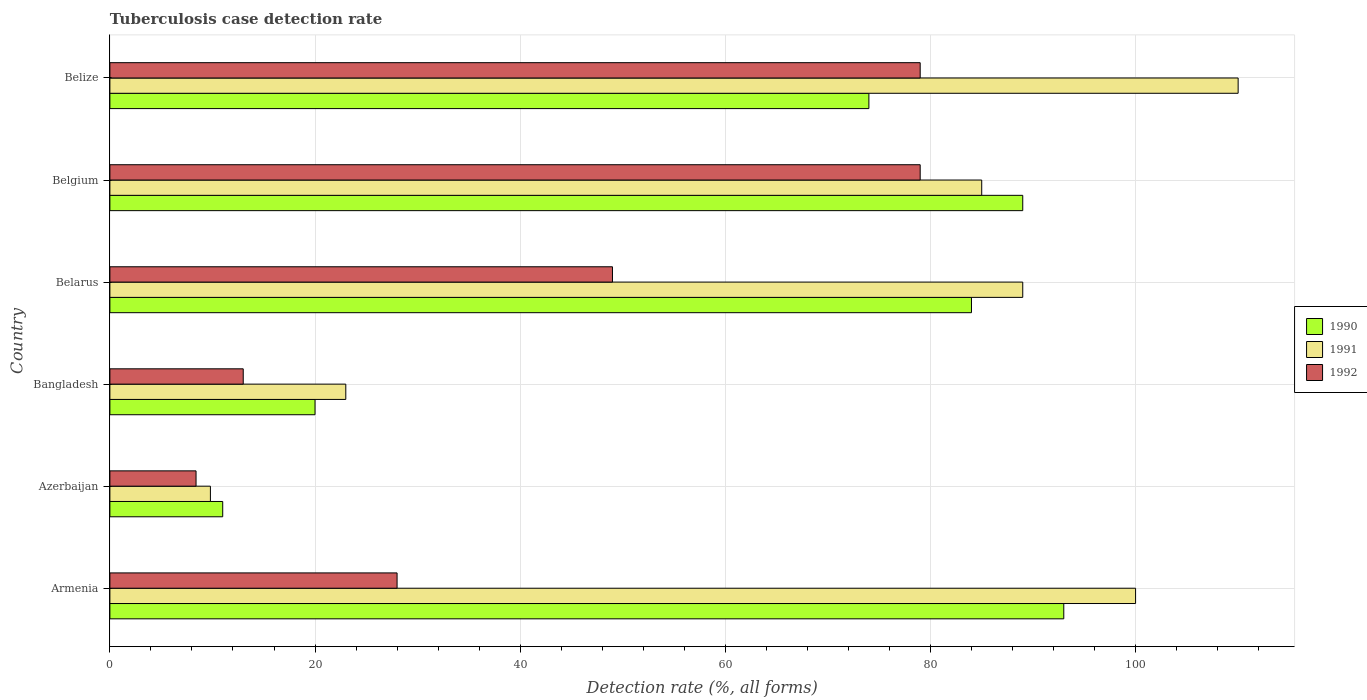How many groups of bars are there?
Offer a very short reply. 6. How many bars are there on the 5th tick from the bottom?
Offer a terse response. 3. What is the label of the 2nd group of bars from the top?
Provide a succinct answer. Belgium. What is the tuberculosis case detection rate in in 1992 in Belgium?
Your answer should be compact. 79. Across all countries, what is the maximum tuberculosis case detection rate in in 1992?
Give a very brief answer. 79. Across all countries, what is the minimum tuberculosis case detection rate in in 1991?
Give a very brief answer. 9.8. In which country was the tuberculosis case detection rate in in 1990 maximum?
Provide a short and direct response. Armenia. In which country was the tuberculosis case detection rate in in 1992 minimum?
Give a very brief answer. Azerbaijan. What is the total tuberculosis case detection rate in in 1992 in the graph?
Offer a very short reply. 256.4. What is the difference between the tuberculosis case detection rate in in 1992 in Belgium and that in Belize?
Offer a terse response. 0. What is the difference between the tuberculosis case detection rate in in 1992 in Belize and the tuberculosis case detection rate in in 1991 in Belarus?
Make the answer very short. -10. What is the average tuberculosis case detection rate in in 1990 per country?
Your answer should be very brief. 61.83. What is the difference between the tuberculosis case detection rate in in 1992 and tuberculosis case detection rate in in 1990 in Belarus?
Make the answer very short. -35. In how many countries, is the tuberculosis case detection rate in in 1990 greater than 28 %?
Your answer should be compact. 4. What is the ratio of the tuberculosis case detection rate in in 1992 in Bangladesh to that in Belgium?
Ensure brevity in your answer.  0.16. Is the tuberculosis case detection rate in in 1992 in Azerbaijan less than that in Belarus?
Keep it short and to the point. Yes. What is the difference between the highest and the second highest tuberculosis case detection rate in in 1992?
Your answer should be very brief. 0. What is the difference between the highest and the lowest tuberculosis case detection rate in in 1991?
Your answer should be compact. 100.2. In how many countries, is the tuberculosis case detection rate in in 1990 greater than the average tuberculosis case detection rate in in 1990 taken over all countries?
Provide a short and direct response. 4. Is the sum of the tuberculosis case detection rate in in 1990 in Armenia and Bangladesh greater than the maximum tuberculosis case detection rate in in 1992 across all countries?
Your answer should be very brief. Yes. What does the 3rd bar from the top in Bangladesh represents?
Ensure brevity in your answer.  1990. Is it the case that in every country, the sum of the tuberculosis case detection rate in in 1991 and tuberculosis case detection rate in in 1992 is greater than the tuberculosis case detection rate in in 1990?
Your answer should be compact. Yes. How many countries are there in the graph?
Offer a terse response. 6. Does the graph contain any zero values?
Offer a terse response. No. Where does the legend appear in the graph?
Provide a short and direct response. Center right. How many legend labels are there?
Your answer should be very brief. 3. How are the legend labels stacked?
Make the answer very short. Vertical. What is the title of the graph?
Make the answer very short. Tuberculosis case detection rate. What is the label or title of the X-axis?
Offer a terse response. Detection rate (%, all forms). What is the label or title of the Y-axis?
Ensure brevity in your answer.  Country. What is the Detection rate (%, all forms) in 1990 in Armenia?
Ensure brevity in your answer.  93. What is the Detection rate (%, all forms) in 1991 in Azerbaijan?
Make the answer very short. 9.8. What is the Detection rate (%, all forms) of 1992 in Azerbaijan?
Offer a terse response. 8.4. What is the Detection rate (%, all forms) of 1992 in Bangladesh?
Keep it short and to the point. 13. What is the Detection rate (%, all forms) of 1990 in Belarus?
Make the answer very short. 84. What is the Detection rate (%, all forms) in 1991 in Belarus?
Your answer should be very brief. 89. What is the Detection rate (%, all forms) of 1992 in Belarus?
Make the answer very short. 49. What is the Detection rate (%, all forms) of 1990 in Belgium?
Your answer should be compact. 89. What is the Detection rate (%, all forms) in 1992 in Belgium?
Make the answer very short. 79. What is the Detection rate (%, all forms) of 1990 in Belize?
Your answer should be very brief. 74. What is the Detection rate (%, all forms) of 1991 in Belize?
Ensure brevity in your answer.  110. What is the Detection rate (%, all forms) in 1992 in Belize?
Provide a short and direct response. 79. Across all countries, what is the maximum Detection rate (%, all forms) in 1990?
Make the answer very short. 93. Across all countries, what is the maximum Detection rate (%, all forms) in 1991?
Make the answer very short. 110. Across all countries, what is the maximum Detection rate (%, all forms) of 1992?
Give a very brief answer. 79. Across all countries, what is the minimum Detection rate (%, all forms) of 1990?
Your answer should be very brief. 11. Across all countries, what is the minimum Detection rate (%, all forms) of 1991?
Keep it short and to the point. 9.8. What is the total Detection rate (%, all forms) in 1990 in the graph?
Provide a succinct answer. 371. What is the total Detection rate (%, all forms) in 1991 in the graph?
Ensure brevity in your answer.  416.8. What is the total Detection rate (%, all forms) of 1992 in the graph?
Give a very brief answer. 256.4. What is the difference between the Detection rate (%, all forms) in 1990 in Armenia and that in Azerbaijan?
Make the answer very short. 82. What is the difference between the Detection rate (%, all forms) in 1991 in Armenia and that in Azerbaijan?
Offer a terse response. 90.2. What is the difference between the Detection rate (%, all forms) in 1992 in Armenia and that in Azerbaijan?
Keep it short and to the point. 19.6. What is the difference between the Detection rate (%, all forms) of 1991 in Armenia and that in Bangladesh?
Your response must be concise. 77. What is the difference between the Detection rate (%, all forms) in 1992 in Armenia and that in Bangladesh?
Offer a very short reply. 15. What is the difference between the Detection rate (%, all forms) in 1990 in Armenia and that in Belarus?
Provide a short and direct response. 9. What is the difference between the Detection rate (%, all forms) of 1991 in Armenia and that in Belarus?
Give a very brief answer. 11. What is the difference between the Detection rate (%, all forms) of 1992 in Armenia and that in Belarus?
Give a very brief answer. -21. What is the difference between the Detection rate (%, all forms) in 1991 in Armenia and that in Belgium?
Make the answer very short. 15. What is the difference between the Detection rate (%, all forms) of 1992 in Armenia and that in Belgium?
Give a very brief answer. -51. What is the difference between the Detection rate (%, all forms) of 1990 in Armenia and that in Belize?
Make the answer very short. 19. What is the difference between the Detection rate (%, all forms) of 1991 in Armenia and that in Belize?
Your answer should be very brief. -10. What is the difference between the Detection rate (%, all forms) in 1992 in Armenia and that in Belize?
Offer a very short reply. -51. What is the difference between the Detection rate (%, all forms) of 1990 in Azerbaijan and that in Bangladesh?
Provide a short and direct response. -9. What is the difference between the Detection rate (%, all forms) in 1991 in Azerbaijan and that in Bangladesh?
Your answer should be compact. -13.2. What is the difference between the Detection rate (%, all forms) in 1992 in Azerbaijan and that in Bangladesh?
Offer a very short reply. -4.6. What is the difference between the Detection rate (%, all forms) of 1990 in Azerbaijan and that in Belarus?
Offer a terse response. -73. What is the difference between the Detection rate (%, all forms) in 1991 in Azerbaijan and that in Belarus?
Your response must be concise. -79.2. What is the difference between the Detection rate (%, all forms) of 1992 in Azerbaijan and that in Belarus?
Provide a succinct answer. -40.6. What is the difference between the Detection rate (%, all forms) of 1990 in Azerbaijan and that in Belgium?
Ensure brevity in your answer.  -78. What is the difference between the Detection rate (%, all forms) of 1991 in Azerbaijan and that in Belgium?
Keep it short and to the point. -75.2. What is the difference between the Detection rate (%, all forms) in 1992 in Azerbaijan and that in Belgium?
Your answer should be compact. -70.6. What is the difference between the Detection rate (%, all forms) of 1990 in Azerbaijan and that in Belize?
Ensure brevity in your answer.  -63. What is the difference between the Detection rate (%, all forms) in 1991 in Azerbaijan and that in Belize?
Give a very brief answer. -100.2. What is the difference between the Detection rate (%, all forms) of 1992 in Azerbaijan and that in Belize?
Provide a short and direct response. -70.6. What is the difference between the Detection rate (%, all forms) in 1990 in Bangladesh and that in Belarus?
Your answer should be very brief. -64. What is the difference between the Detection rate (%, all forms) in 1991 in Bangladesh and that in Belarus?
Offer a very short reply. -66. What is the difference between the Detection rate (%, all forms) in 1992 in Bangladesh and that in Belarus?
Provide a succinct answer. -36. What is the difference between the Detection rate (%, all forms) of 1990 in Bangladesh and that in Belgium?
Keep it short and to the point. -69. What is the difference between the Detection rate (%, all forms) in 1991 in Bangladesh and that in Belgium?
Offer a terse response. -62. What is the difference between the Detection rate (%, all forms) of 1992 in Bangladesh and that in Belgium?
Ensure brevity in your answer.  -66. What is the difference between the Detection rate (%, all forms) in 1990 in Bangladesh and that in Belize?
Your answer should be very brief. -54. What is the difference between the Detection rate (%, all forms) in 1991 in Bangladesh and that in Belize?
Provide a succinct answer. -87. What is the difference between the Detection rate (%, all forms) in 1992 in Bangladesh and that in Belize?
Offer a terse response. -66. What is the difference between the Detection rate (%, all forms) of 1990 in Belarus and that in Belgium?
Provide a short and direct response. -5. What is the difference between the Detection rate (%, all forms) of 1991 in Belarus and that in Belgium?
Keep it short and to the point. 4. What is the difference between the Detection rate (%, all forms) of 1990 in Belarus and that in Belize?
Give a very brief answer. 10. What is the difference between the Detection rate (%, all forms) in 1990 in Belgium and that in Belize?
Your answer should be compact. 15. What is the difference between the Detection rate (%, all forms) in 1992 in Belgium and that in Belize?
Your response must be concise. 0. What is the difference between the Detection rate (%, all forms) of 1990 in Armenia and the Detection rate (%, all forms) of 1991 in Azerbaijan?
Give a very brief answer. 83.2. What is the difference between the Detection rate (%, all forms) in 1990 in Armenia and the Detection rate (%, all forms) in 1992 in Azerbaijan?
Offer a terse response. 84.6. What is the difference between the Detection rate (%, all forms) in 1991 in Armenia and the Detection rate (%, all forms) in 1992 in Azerbaijan?
Provide a short and direct response. 91.6. What is the difference between the Detection rate (%, all forms) in 1990 in Armenia and the Detection rate (%, all forms) in 1991 in Bangladesh?
Provide a short and direct response. 70. What is the difference between the Detection rate (%, all forms) in 1990 in Armenia and the Detection rate (%, all forms) in 1992 in Bangladesh?
Offer a terse response. 80. What is the difference between the Detection rate (%, all forms) of 1990 in Armenia and the Detection rate (%, all forms) of 1992 in Belize?
Your response must be concise. 14. What is the difference between the Detection rate (%, all forms) in 1991 in Armenia and the Detection rate (%, all forms) in 1992 in Belize?
Provide a succinct answer. 21. What is the difference between the Detection rate (%, all forms) in 1990 in Azerbaijan and the Detection rate (%, all forms) in 1991 in Bangladesh?
Offer a terse response. -12. What is the difference between the Detection rate (%, all forms) of 1991 in Azerbaijan and the Detection rate (%, all forms) of 1992 in Bangladesh?
Your answer should be very brief. -3.2. What is the difference between the Detection rate (%, all forms) in 1990 in Azerbaijan and the Detection rate (%, all forms) in 1991 in Belarus?
Provide a succinct answer. -78. What is the difference between the Detection rate (%, all forms) in 1990 in Azerbaijan and the Detection rate (%, all forms) in 1992 in Belarus?
Offer a very short reply. -38. What is the difference between the Detection rate (%, all forms) in 1991 in Azerbaijan and the Detection rate (%, all forms) in 1992 in Belarus?
Provide a short and direct response. -39.2. What is the difference between the Detection rate (%, all forms) in 1990 in Azerbaijan and the Detection rate (%, all forms) in 1991 in Belgium?
Offer a very short reply. -74. What is the difference between the Detection rate (%, all forms) of 1990 in Azerbaijan and the Detection rate (%, all forms) of 1992 in Belgium?
Provide a short and direct response. -68. What is the difference between the Detection rate (%, all forms) in 1991 in Azerbaijan and the Detection rate (%, all forms) in 1992 in Belgium?
Give a very brief answer. -69.2. What is the difference between the Detection rate (%, all forms) of 1990 in Azerbaijan and the Detection rate (%, all forms) of 1991 in Belize?
Your answer should be very brief. -99. What is the difference between the Detection rate (%, all forms) in 1990 in Azerbaijan and the Detection rate (%, all forms) in 1992 in Belize?
Give a very brief answer. -68. What is the difference between the Detection rate (%, all forms) in 1991 in Azerbaijan and the Detection rate (%, all forms) in 1992 in Belize?
Your answer should be compact. -69.2. What is the difference between the Detection rate (%, all forms) in 1990 in Bangladesh and the Detection rate (%, all forms) in 1991 in Belarus?
Your response must be concise. -69. What is the difference between the Detection rate (%, all forms) in 1990 in Bangladesh and the Detection rate (%, all forms) in 1991 in Belgium?
Offer a very short reply. -65. What is the difference between the Detection rate (%, all forms) of 1990 in Bangladesh and the Detection rate (%, all forms) of 1992 in Belgium?
Your answer should be very brief. -59. What is the difference between the Detection rate (%, all forms) of 1991 in Bangladesh and the Detection rate (%, all forms) of 1992 in Belgium?
Offer a terse response. -56. What is the difference between the Detection rate (%, all forms) of 1990 in Bangladesh and the Detection rate (%, all forms) of 1991 in Belize?
Offer a very short reply. -90. What is the difference between the Detection rate (%, all forms) of 1990 in Bangladesh and the Detection rate (%, all forms) of 1992 in Belize?
Your answer should be very brief. -59. What is the difference between the Detection rate (%, all forms) of 1991 in Bangladesh and the Detection rate (%, all forms) of 1992 in Belize?
Offer a terse response. -56. What is the difference between the Detection rate (%, all forms) in 1990 in Belarus and the Detection rate (%, all forms) in 1991 in Belgium?
Give a very brief answer. -1. What is the difference between the Detection rate (%, all forms) of 1991 in Belarus and the Detection rate (%, all forms) of 1992 in Belgium?
Keep it short and to the point. 10. What is the difference between the Detection rate (%, all forms) of 1990 in Belarus and the Detection rate (%, all forms) of 1992 in Belize?
Provide a short and direct response. 5. What is the difference between the Detection rate (%, all forms) of 1990 in Belgium and the Detection rate (%, all forms) of 1992 in Belize?
Ensure brevity in your answer.  10. What is the difference between the Detection rate (%, all forms) of 1991 in Belgium and the Detection rate (%, all forms) of 1992 in Belize?
Provide a succinct answer. 6. What is the average Detection rate (%, all forms) of 1990 per country?
Make the answer very short. 61.83. What is the average Detection rate (%, all forms) in 1991 per country?
Your response must be concise. 69.47. What is the average Detection rate (%, all forms) of 1992 per country?
Offer a very short reply. 42.73. What is the difference between the Detection rate (%, all forms) of 1990 and Detection rate (%, all forms) of 1991 in Armenia?
Make the answer very short. -7. What is the difference between the Detection rate (%, all forms) of 1990 and Detection rate (%, all forms) of 1992 in Armenia?
Provide a short and direct response. 65. What is the difference between the Detection rate (%, all forms) of 1991 and Detection rate (%, all forms) of 1992 in Armenia?
Ensure brevity in your answer.  72. What is the difference between the Detection rate (%, all forms) of 1990 and Detection rate (%, all forms) of 1991 in Bangladesh?
Provide a short and direct response. -3. What is the difference between the Detection rate (%, all forms) of 1991 and Detection rate (%, all forms) of 1992 in Bangladesh?
Give a very brief answer. 10. What is the difference between the Detection rate (%, all forms) of 1990 and Detection rate (%, all forms) of 1991 in Belarus?
Offer a terse response. -5. What is the difference between the Detection rate (%, all forms) in 1991 and Detection rate (%, all forms) in 1992 in Belarus?
Provide a short and direct response. 40. What is the difference between the Detection rate (%, all forms) in 1990 and Detection rate (%, all forms) in 1991 in Belgium?
Your response must be concise. 4. What is the difference between the Detection rate (%, all forms) in 1990 and Detection rate (%, all forms) in 1991 in Belize?
Keep it short and to the point. -36. What is the difference between the Detection rate (%, all forms) in 1991 and Detection rate (%, all forms) in 1992 in Belize?
Provide a succinct answer. 31. What is the ratio of the Detection rate (%, all forms) of 1990 in Armenia to that in Azerbaijan?
Offer a terse response. 8.45. What is the ratio of the Detection rate (%, all forms) of 1991 in Armenia to that in Azerbaijan?
Keep it short and to the point. 10.2. What is the ratio of the Detection rate (%, all forms) in 1990 in Armenia to that in Bangladesh?
Give a very brief answer. 4.65. What is the ratio of the Detection rate (%, all forms) of 1991 in Armenia to that in Bangladesh?
Give a very brief answer. 4.35. What is the ratio of the Detection rate (%, all forms) of 1992 in Armenia to that in Bangladesh?
Ensure brevity in your answer.  2.15. What is the ratio of the Detection rate (%, all forms) in 1990 in Armenia to that in Belarus?
Your answer should be very brief. 1.11. What is the ratio of the Detection rate (%, all forms) of 1991 in Armenia to that in Belarus?
Give a very brief answer. 1.12. What is the ratio of the Detection rate (%, all forms) in 1992 in Armenia to that in Belarus?
Offer a terse response. 0.57. What is the ratio of the Detection rate (%, all forms) in 1990 in Armenia to that in Belgium?
Your response must be concise. 1.04. What is the ratio of the Detection rate (%, all forms) of 1991 in Armenia to that in Belgium?
Make the answer very short. 1.18. What is the ratio of the Detection rate (%, all forms) of 1992 in Armenia to that in Belgium?
Provide a succinct answer. 0.35. What is the ratio of the Detection rate (%, all forms) of 1990 in Armenia to that in Belize?
Make the answer very short. 1.26. What is the ratio of the Detection rate (%, all forms) in 1991 in Armenia to that in Belize?
Your answer should be very brief. 0.91. What is the ratio of the Detection rate (%, all forms) of 1992 in Armenia to that in Belize?
Ensure brevity in your answer.  0.35. What is the ratio of the Detection rate (%, all forms) of 1990 in Azerbaijan to that in Bangladesh?
Give a very brief answer. 0.55. What is the ratio of the Detection rate (%, all forms) of 1991 in Azerbaijan to that in Bangladesh?
Ensure brevity in your answer.  0.43. What is the ratio of the Detection rate (%, all forms) in 1992 in Azerbaijan to that in Bangladesh?
Provide a succinct answer. 0.65. What is the ratio of the Detection rate (%, all forms) in 1990 in Azerbaijan to that in Belarus?
Offer a very short reply. 0.13. What is the ratio of the Detection rate (%, all forms) in 1991 in Azerbaijan to that in Belarus?
Give a very brief answer. 0.11. What is the ratio of the Detection rate (%, all forms) of 1992 in Azerbaijan to that in Belarus?
Offer a terse response. 0.17. What is the ratio of the Detection rate (%, all forms) of 1990 in Azerbaijan to that in Belgium?
Give a very brief answer. 0.12. What is the ratio of the Detection rate (%, all forms) in 1991 in Azerbaijan to that in Belgium?
Make the answer very short. 0.12. What is the ratio of the Detection rate (%, all forms) in 1992 in Azerbaijan to that in Belgium?
Your response must be concise. 0.11. What is the ratio of the Detection rate (%, all forms) of 1990 in Azerbaijan to that in Belize?
Keep it short and to the point. 0.15. What is the ratio of the Detection rate (%, all forms) in 1991 in Azerbaijan to that in Belize?
Offer a very short reply. 0.09. What is the ratio of the Detection rate (%, all forms) in 1992 in Azerbaijan to that in Belize?
Offer a terse response. 0.11. What is the ratio of the Detection rate (%, all forms) of 1990 in Bangladesh to that in Belarus?
Provide a succinct answer. 0.24. What is the ratio of the Detection rate (%, all forms) of 1991 in Bangladesh to that in Belarus?
Provide a short and direct response. 0.26. What is the ratio of the Detection rate (%, all forms) in 1992 in Bangladesh to that in Belarus?
Ensure brevity in your answer.  0.27. What is the ratio of the Detection rate (%, all forms) of 1990 in Bangladesh to that in Belgium?
Your answer should be very brief. 0.22. What is the ratio of the Detection rate (%, all forms) of 1991 in Bangladesh to that in Belgium?
Provide a short and direct response. 0.27. What is the ratio of the Detection rate (%, all forms) of 1992 in Bangladesh to that in Belgium?
Your answer should be very brief. 0.16. What is the ratio of the Detection rate (%, all forms) in 1990 in Bangladesh to that in Belize?
Keep it short and to the point. 0.27. What is the ratio of the Detection rate (%, all forms) in 1991 in Bangladesh to that in Belize?
Your answer should be very brief. 0.21. What is the ratio of the Detection rate (%, all forms) of 1992 in Bangladesh to that in Belize?
Your answer should be very brief. 0.16. What is the ratio of the Detection rate (%, all forms) in 1990 in Belarus to that in Belgium?
Your response must be concise. 0.94. What is the ratio of the Detection rate (%, all forms) in 1991 in Belarus to that in Belgium?
Offer a terse response. 1.05. What is the ratio of the Detection rate (%, all forms) of 1992 in Belarus to that in Belgium?
Offer a terse response. 0.62. What is the ratio of the Detection rate (%, all forms) in 1990 in Belarus to that in Belize?
Your answer should be compact. 1.14. What is the ratio of the Detection rate (%, all forms) of 1991 in Belarus to that in Belize?
Provide a short and direct response. 0.81. What is the ratio of the Detection rate (%, all forms) of 1992 in Belarus to that in Belize?
Ensure brevity in your answer.  0.62. What is the ratio of the Detection rate (%, all forms) of 1990 in Belgium to that in Belize?
Make the answer very short. 1.2. What is the ratio of the Detection rate (%, all forms) in 1991 in Belgium to that in Belize?
Give a very brief answer. 0.77. What is the difference between the highest and the lowest Detection rate (%, all forms) of 1990?
Your answer should be compact. 82. What is the difference between the highest and the lowest Detection rate (%, all forms) of 1991?
Ensure brevity in your answer.  100.2. What is the difference between the highest and the lowest Detection rate (%, all forms) of 1992?
Your answer should be compact. 70.6. 